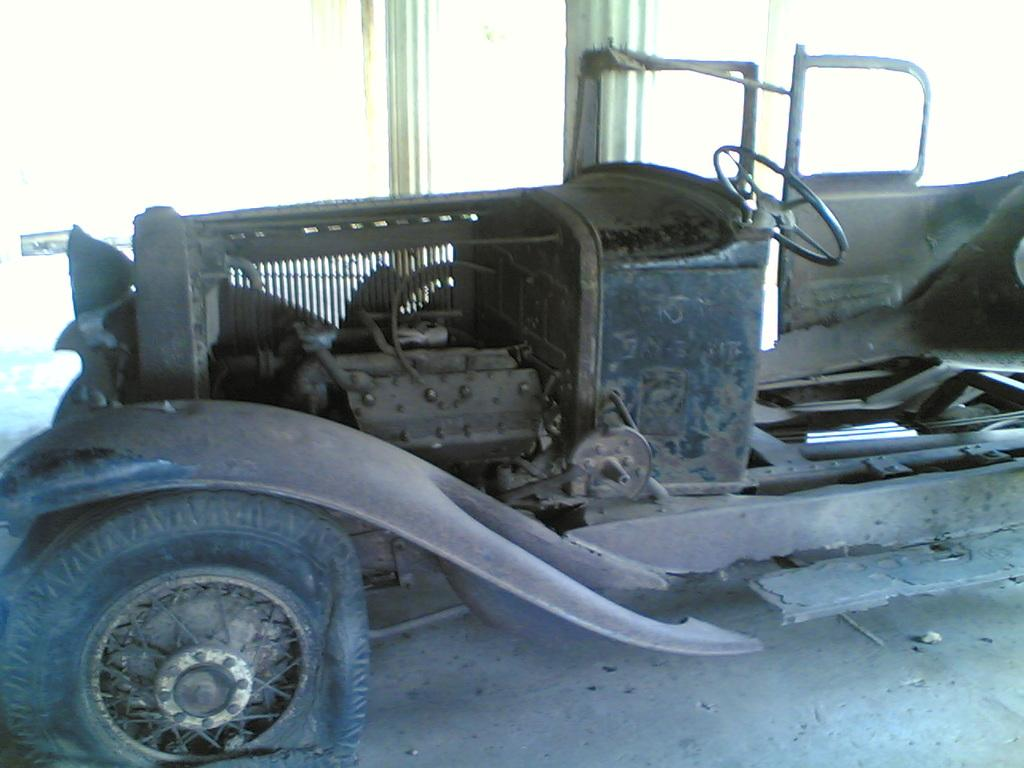What type of vehicle is in the image? There is an old vehicle in the image. What color is the vehicle? The vehicle is brown in color. What architectural elements can be seen in the image? There are pillars visible in the image. Where is the vehicle located in the image? The vehicle is parked on the floor. How much did the jelly increase in size after being placed in the vehicle? There is no jelly present in the image, so it cannot be determined if any jelly was placed in the vehicle or if its size increased. 